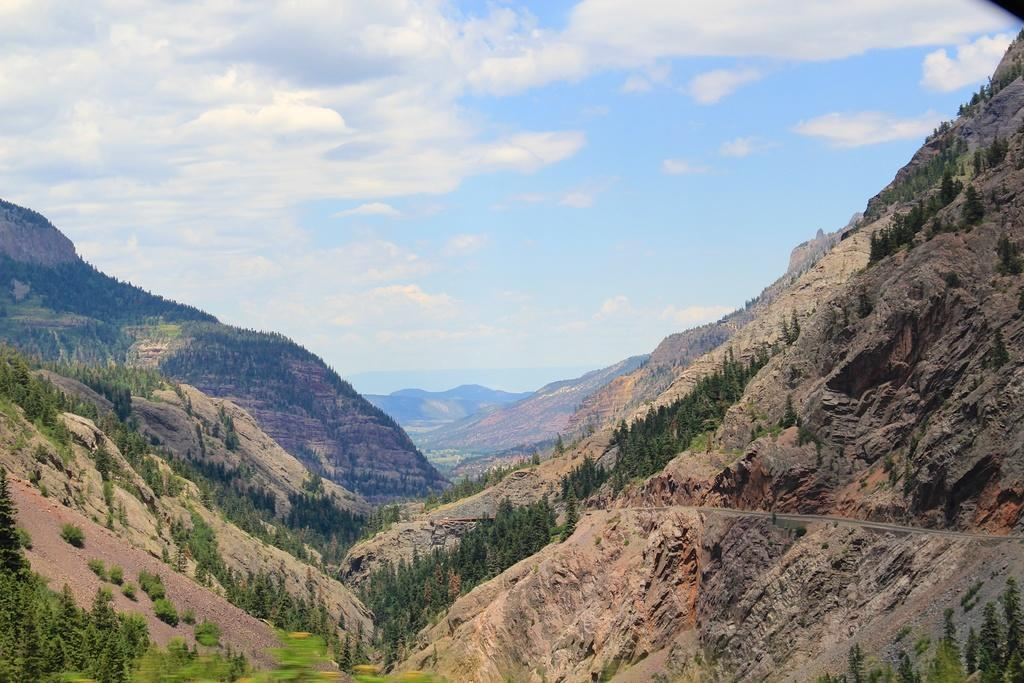What type of natural feature is present on the mountains in the image? There is a group of trees on the mountains in the image. What can be seen on the right side of the image? There is a pathway on the hill on the right side of the image. What is the condition of the sky in the image? The sky is visible in the image and appears cloudy. Can you tell me how many spies are hidden in the trees in the image? There is no mention of spies in the image; it features a group of trees on the mountains. What direction does the pathway turn on the right side of the image? The image does not provide information about the direction the pathway turns; it only shows the presence of a pathway on the hill. 